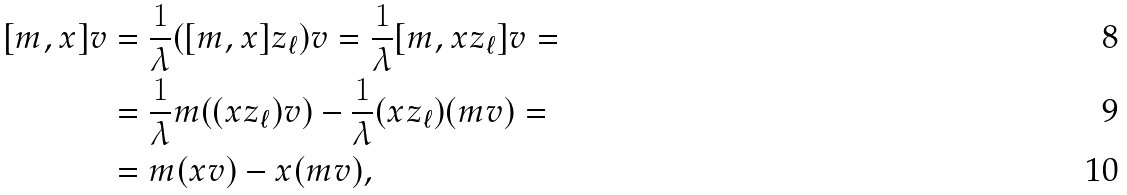<formula> <loc_0><loc_0><loc_500><loc_500>[ m , x ] v & = \frac { 1 } \lambda ( [ m , x ] z _ { \ell } ) v = \frac { 1 } \lambda [ m , x z _ { \ell } ] v = \\ & = \frac { 1 } \lambda m ( ( x z _ { \ell } ) v ) - \frac { 1 } \lambda ( x z _ { \ell } ) ( m v ) = \\ & = m ( x v ) - x ( m v ) ,</formula> 